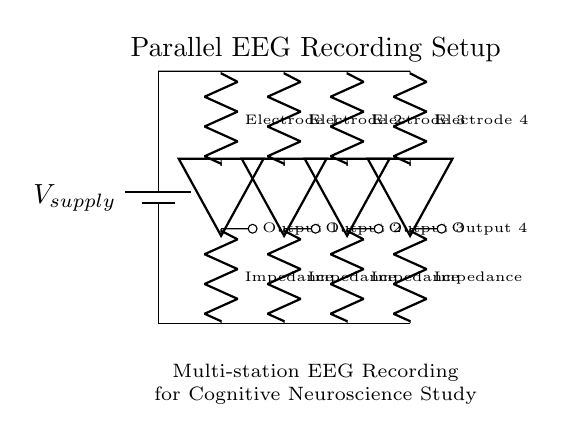What is the total number of EEG stations in this circuit? The circuit diagram clearly shows four distinct EEG stations, each represented with unique labels. This is visually identifiable by the connections and the individual components labeled as "Electrode 1", "Electrode 2", "Electrode 3", and "Electrode 4".
Answer: Four What type of circuit is displayed in the diagram? The configuration of the EEG stations connected in parallel suggests that the overall structure is that of a parallel circuit. Each electrode connects directly to the voltage supply parallel to one another, allowing them to operate independently.
Answer: Parallel What is the role of the components labeled "Impedance"? "Impedance" in this context signifies that each electrode station has a built-in impedance component, which measures resistance and reactance against the EEG signals generated. Impedance is crucial for ensuring accurate data capture across various frequencies.
Answer: Measurement How many output lines are there in the circuit? From the diagram, each EEG station has a corresponding output line extending outward. Counting these, there are also four outputs labeled "Output 1", "Output 2", "Output 3", and "Output 4".
Answer: Four What is the function of the component labeled "V_supply"? The "V_supply" serves as the primary power source for the EEG recording setup. This component provides the necessary voltage needed to operate all connected EEG stations effectively.
Answer: Power supply What does the label "Parallel EEG Recording Setup" indicate? The label "Parallel EEG Recording Setup" indicates that this circuit configuration is specifically designed to facilitate multi-channel EEG recordings, where signals from different electrodes are measured simultaneously during cognitive tests.
Answer: Multi-channel EEG 